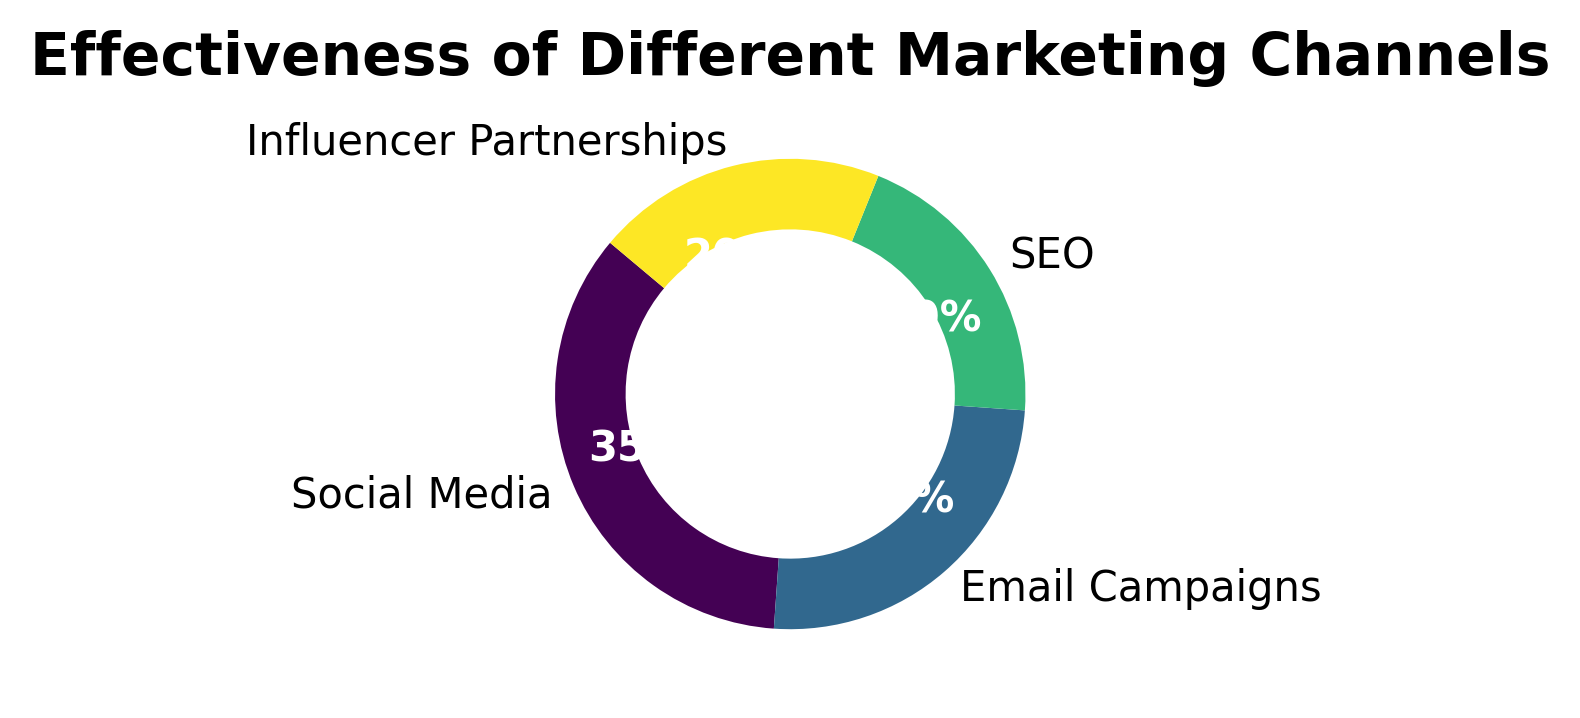Which marketing channel is shown to be the most effective? The pie chart shows the channels with percentages, and the one with the largest percentage will be the most effective. Here, Social Media has the highest percentage at 35%.
Answer: Social Media What is the combined effectiveness percentage of SEO and Influencer Partnerships? To find the combined percentage, add the effectiveness percentages of SEO and Influencer Partnerships. From the chart, each has an effectiveness of 20%. So, 20% + 20% = 40%.
Answer: 40% Compare the effectiveness of Social Media with Email Campaigns. Which one is more effective and by how much? The pie chart shows Social Media at 35% and Email Campaigns at 25%. By subtracting the smaller percentage from the larger one, 35% - 25%, we find that Social Media is more effective by 10%.
Answer: Social Media is more effective by 10% Which two marketing channels have equal effectiveness percentages? The pie chart shows SEO and Influencer Partnerships both with an effectiveness percentage of 20%. So, these two channels have equal effectiveness.
Answer: SEO and Influencer Partnerships What percentage of the total effectiveness is attributed to Social Media and Email Campaigns combined? Add the effectiveness percentages of Social Media and Email Campaigns. Social Media is 35%, and Email Campaigns is 25%. So, 35% + 25% = 60%.
Answer: 60% What is the difference in effectiveness percentage between the highest and lowest effective marketing channels? The highest percentage is Social Media at 35%, and the lowest percentages are SEO and Influencer Partnerships both at 20%. Subtracting the lowest from the highest, 35% - 20%, gives the difference.
Answer: 15% If you were to recommend increasing focus on two marketing channels based on their combined effectiveness, which channels would you choose? To determine this, we should find the pair with the highest combined effectiveness. Social Media & Email Campaigns combined effectiveness is 60%, which is higher than any other pair.
Answer: Social Media and Email Campaigns How do the visual colors of the sections help in differentiating the marketing channels? The pie chart uses different colors for each section to represent the various marketing channels, making it visually easier to identify and differentiate them.
Answer: Helps differentiate channels visually What can be inferred from the fact that no single channel has over 50% effectiveness? This indicates no single marketing channel dominates, suggesting a diversified approach in marketing efforts might be beneficial.
Answer: Diverse marketing strategy is necessary 